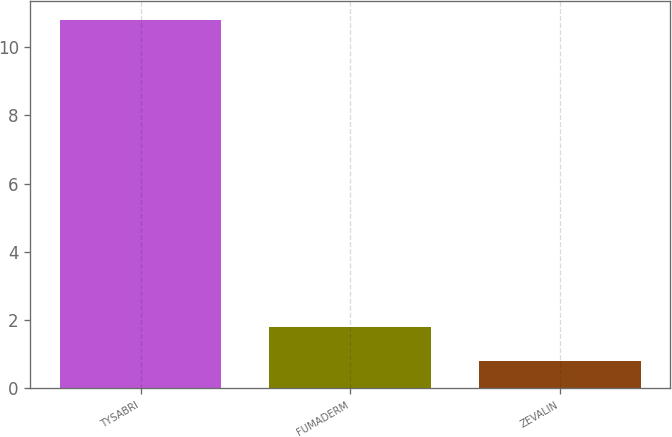Convert chart to OTSL. <chart><loc_0><loc_0><loc_500><loc_500><bar_chart><fcel>TYSABRI<fcel>FUMADERM<fcel>ZEVALIN<nl><fcel>10.8<fcel>1.8<fcel>0.8<nl></chart> 